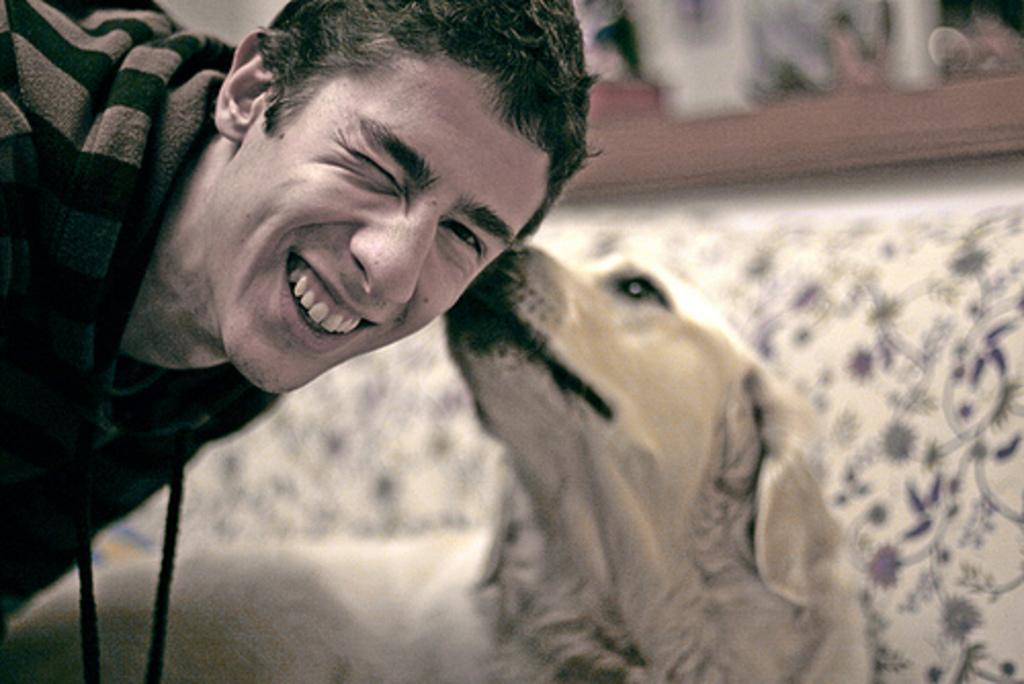Who is present in the image? There is a man in the image. What is the man doing in the image? The man is smiling in the image. What other living creature is present in the image? There is a dog in the image. What is the dog doing in the image? The dog is sniffing the man's head. What can be seen in the background of the image? There is a sofa in the background of the image. What type of destruction can be seen in the image? There is no destruction present in the image. What smell is the dog reacting to in the image? The image does not provide information about any specific smell that the dog might be reacting to. 